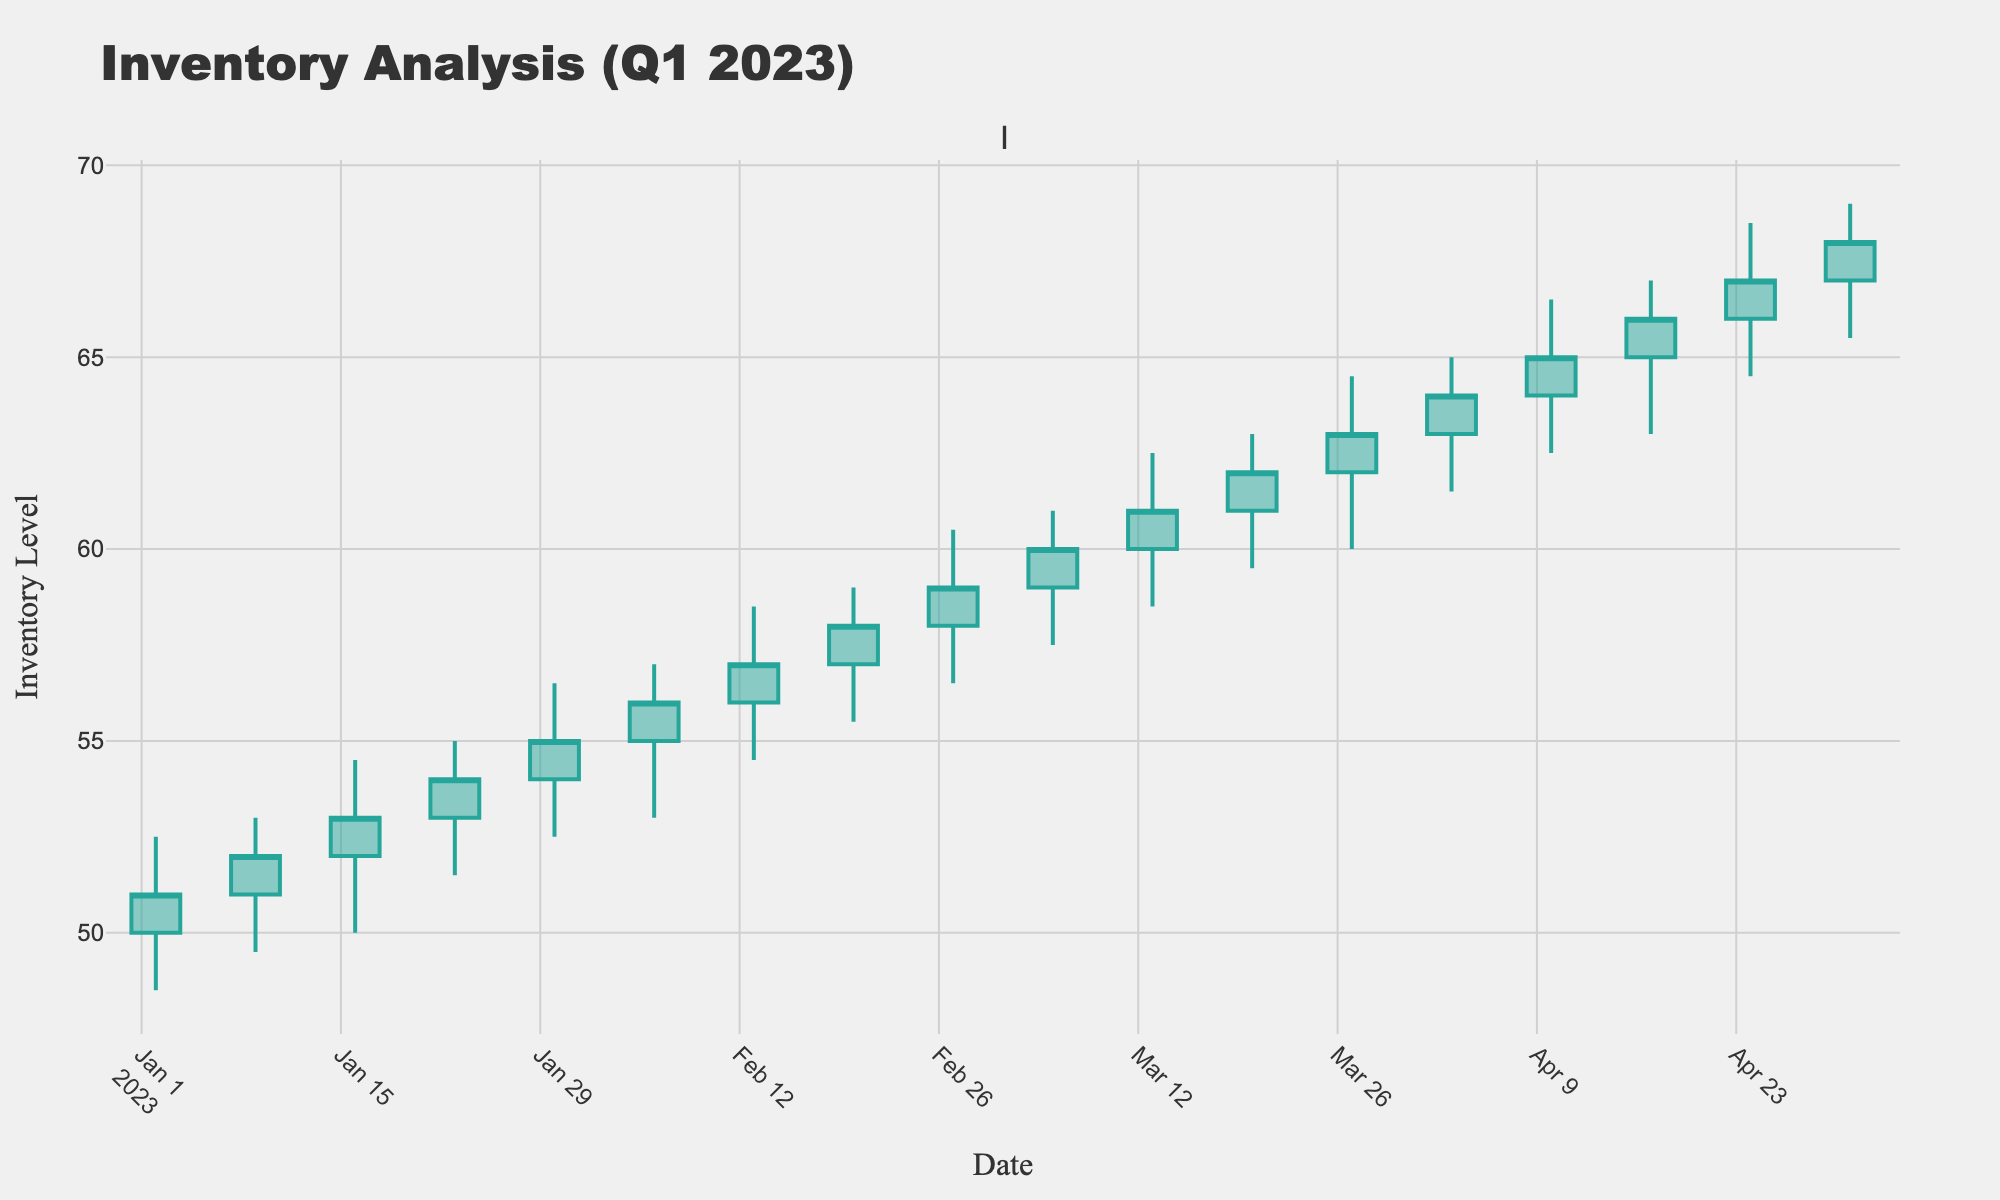What is the title of the figure? The title can be found at the top of the plot, it reads "Inventory Analysis (Q1 2023)".
Answer: Inventory Analysis (Q1 2023) What is the color of the increasing lines in the candlestick plot? The increasing lines are visually shown in the figure with a greenish color.
Answer: Greenish How many data points are displayed in the figure? Count the number of candlesticks, each representing a single data point.
Answer: 17 What is the range of dates covered in the candlestick plot? The x-axis indicates the chronological progression from the starting to the ending date.
Answer: 2023-01-02 to 2023-05-01 What is the lowest inventory level recorded in the first quarter of 2023? Examine the lowest point of the lowest candlestick in the plot.
Answer: Around 48.50 What is the highest closing inventory level recorded in the first quarter of 2023? Look for the highest point of any closing value in the candlestick plot.
Answer: 68.00 How does the inventory level trend overall during Q1 2023? Observe the general direction of the Candlestick Chart from the start date to the end date. It shows a general increase.
Answer: Increasing Which week shows the highest fluctuation in inventory levels? Identify the week with the tallest candlestick, represented by the difference between the high and low values.
Answer: Week starting 2023-02-27 How many weeks does the inventory level close higher than it opened within the first quarter of 2023? Count the number of candlesticks where the closing price is higher than the opening price by comparing the top and bottom parts of the candle.
Answer: 9 Which week did the inventory level first surpass 60? Find the earliest candlestick where the closing price exceeds 60 by checking each week's closing values.
Answer: Week starting 2023-03-13 